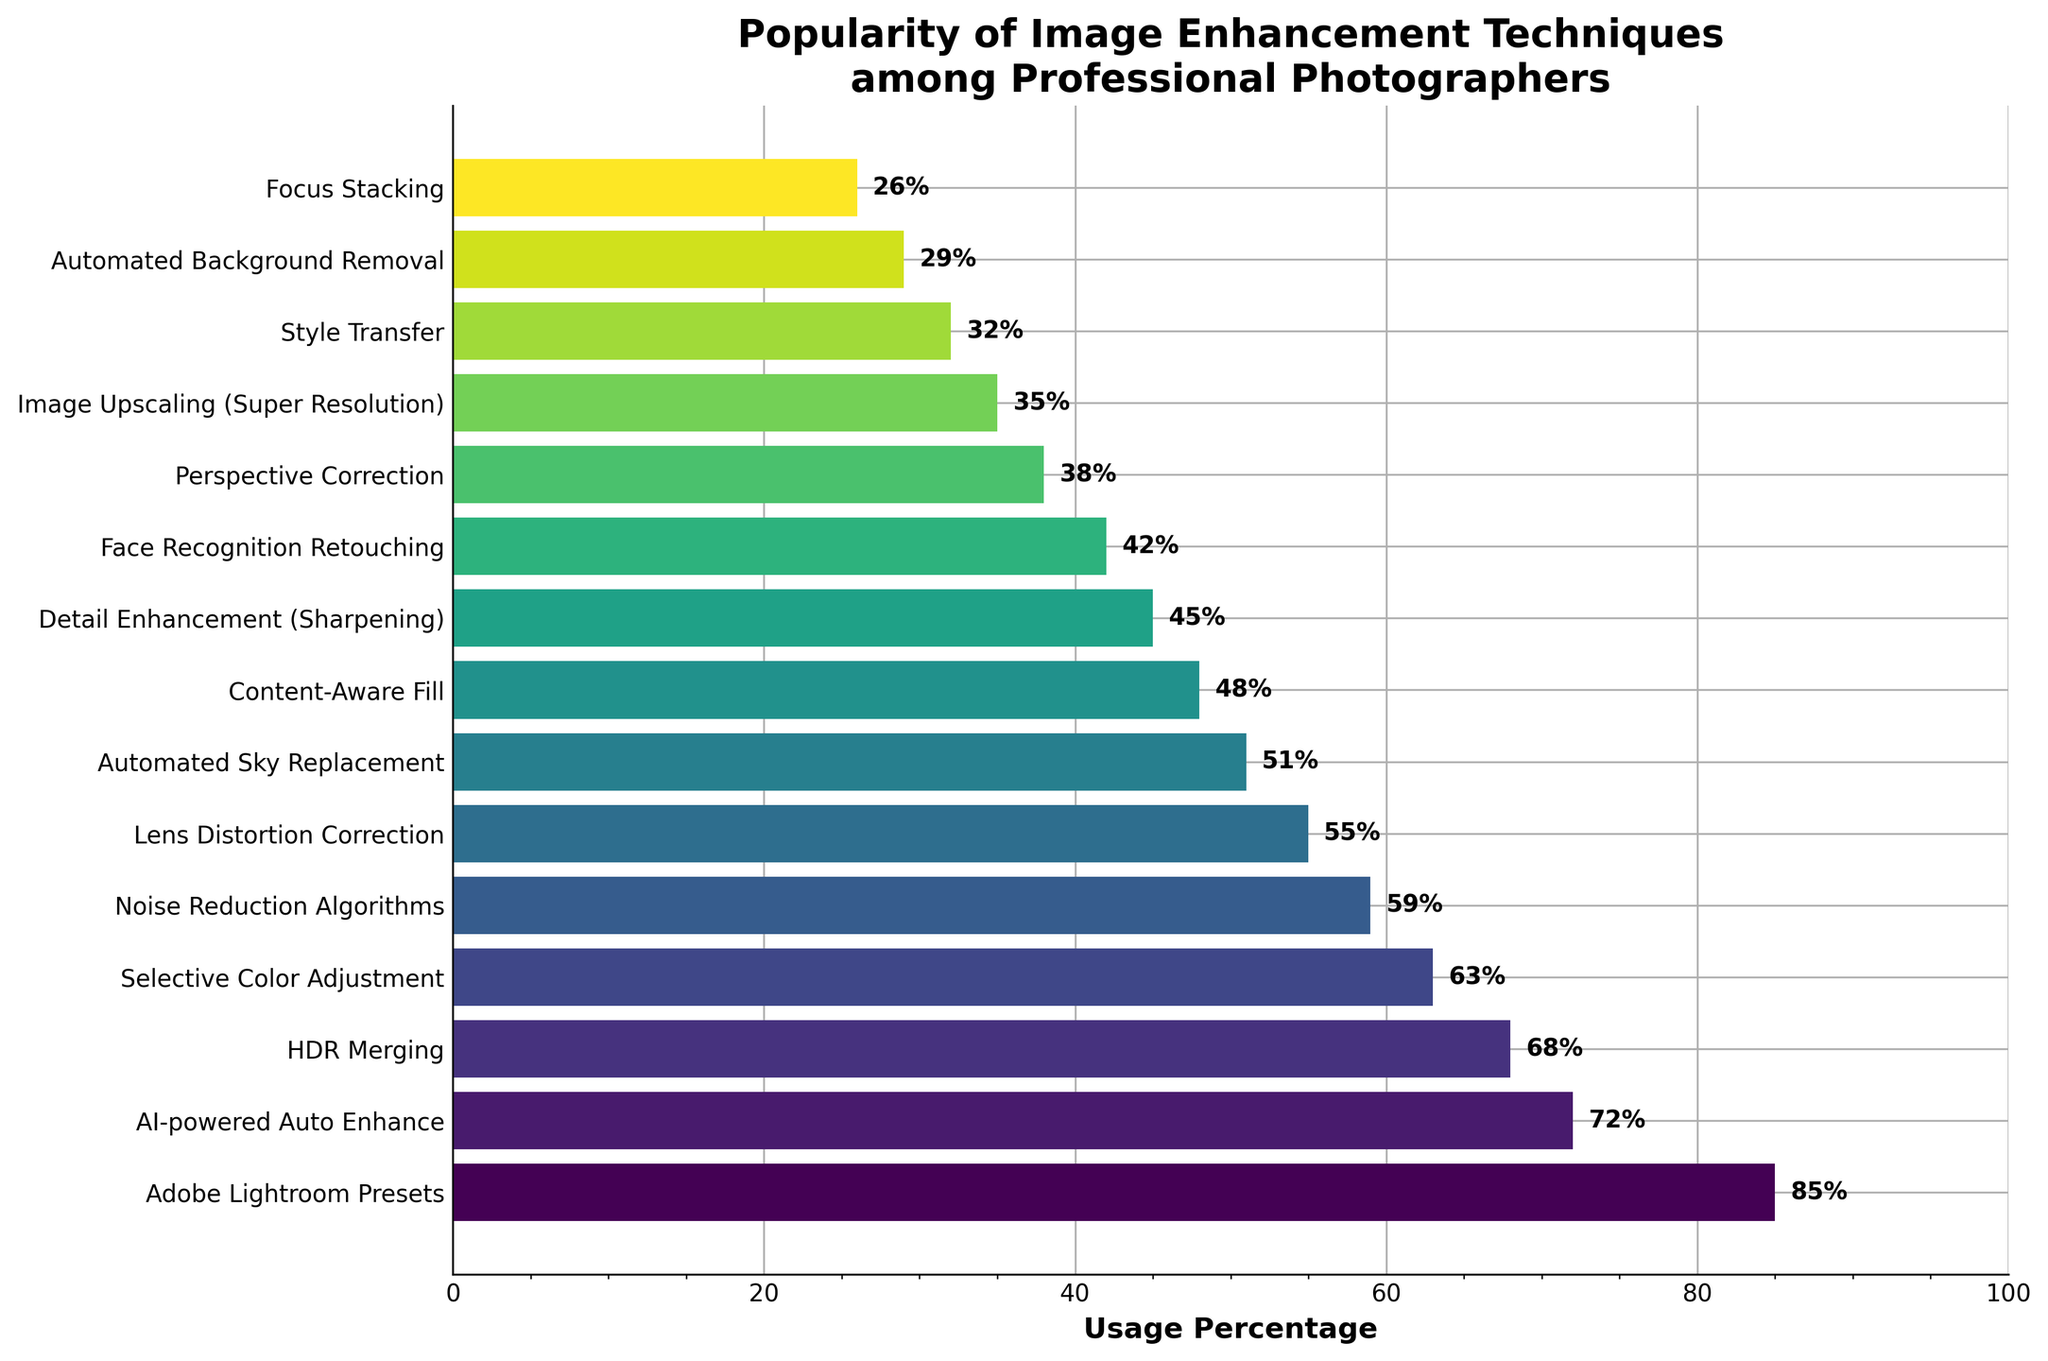What's the most popular image enhancement technique among professional photographers? The technique with the highest bar represents the most popular one. Adobe Lightroom Presets has the highest bar at 85%.
Answer: Adobe Lightroom Presets Which technique is less popular: Noise Reduction Algorithms or Detail Enhancement (Sharpening)? Compare the heights of the bars for Noise Reduction Algorithms (59%) and Detail Enhancement (45%). 59% is higher than 45%, so Detail Enhancement is less popular.
Answer: Detail Enhancement What are the combined usage percentages of HDR Merging and Selective Color Adjustment? Add the usage percentages of HDR Merging (68%) and Selective Color Adjustment (63%). 68 + 63 = 131.
Answer: 131% How many techniques have a usage percentage greater than 50%? Count the bars with heights greater than 50%. There are 7 techniques: Adobe Lightroom Presets, AI-powered Auto Enhance, HDR Merging, Selective Color Adjustment, Noise Reduction Algorithms, Lens Distortion Correction, and Automated Sky Replacement.
Answer: 7 Which technique falls exactly in the middle in terms of popularity? With 15 techniques, the one in the 8th position when sorted is in the middle. The 8th technique is Content-Aware Fill with 48%.
Answer: Content-Aware Fill How does the popularity of AI-powered Auto Enhance compare to Lens Distortion Correction? Compare the bars for AI-powered Auto Enhance (72%) and Lens Distortion Correction (55%). The bar for AI-powered Auto Enhance is taller, indicating it is more popular.
Answer: AI-powered Auto Enhance is more popular What is the difference in usage percentage between Automated Background Removal and Focus Stacking? Subtract the usage percentage of Focus Stacking (26%) from Automated Background Removal (29%). 29 - 26 = 3.
Answer: 3% Which two techniques have the closest usage percentages? Look for the pair of bars with the smallest difference in heights. The closest are Content-Aware Fill (48%) and Detail Enhancement (45%) with a difference of 3.
Answer: Content-Aware Fill and Detail Enhancement What technique is just above Noise Reduction Algorithms in popularity? The technique directly above Noise Reduction Algorithms (59%) is Selective Color Adjustment with 63%.
Answer: Selective Color Adjustment How many techniques have a usage percentage below 40%? Count the bars with heights lower than 40%. There are 5 techniques: Face Recognition Retouching, Perspective Correction, Image Upscaling, Style Transfer, and Automated Background Removal.
Answer: 5 